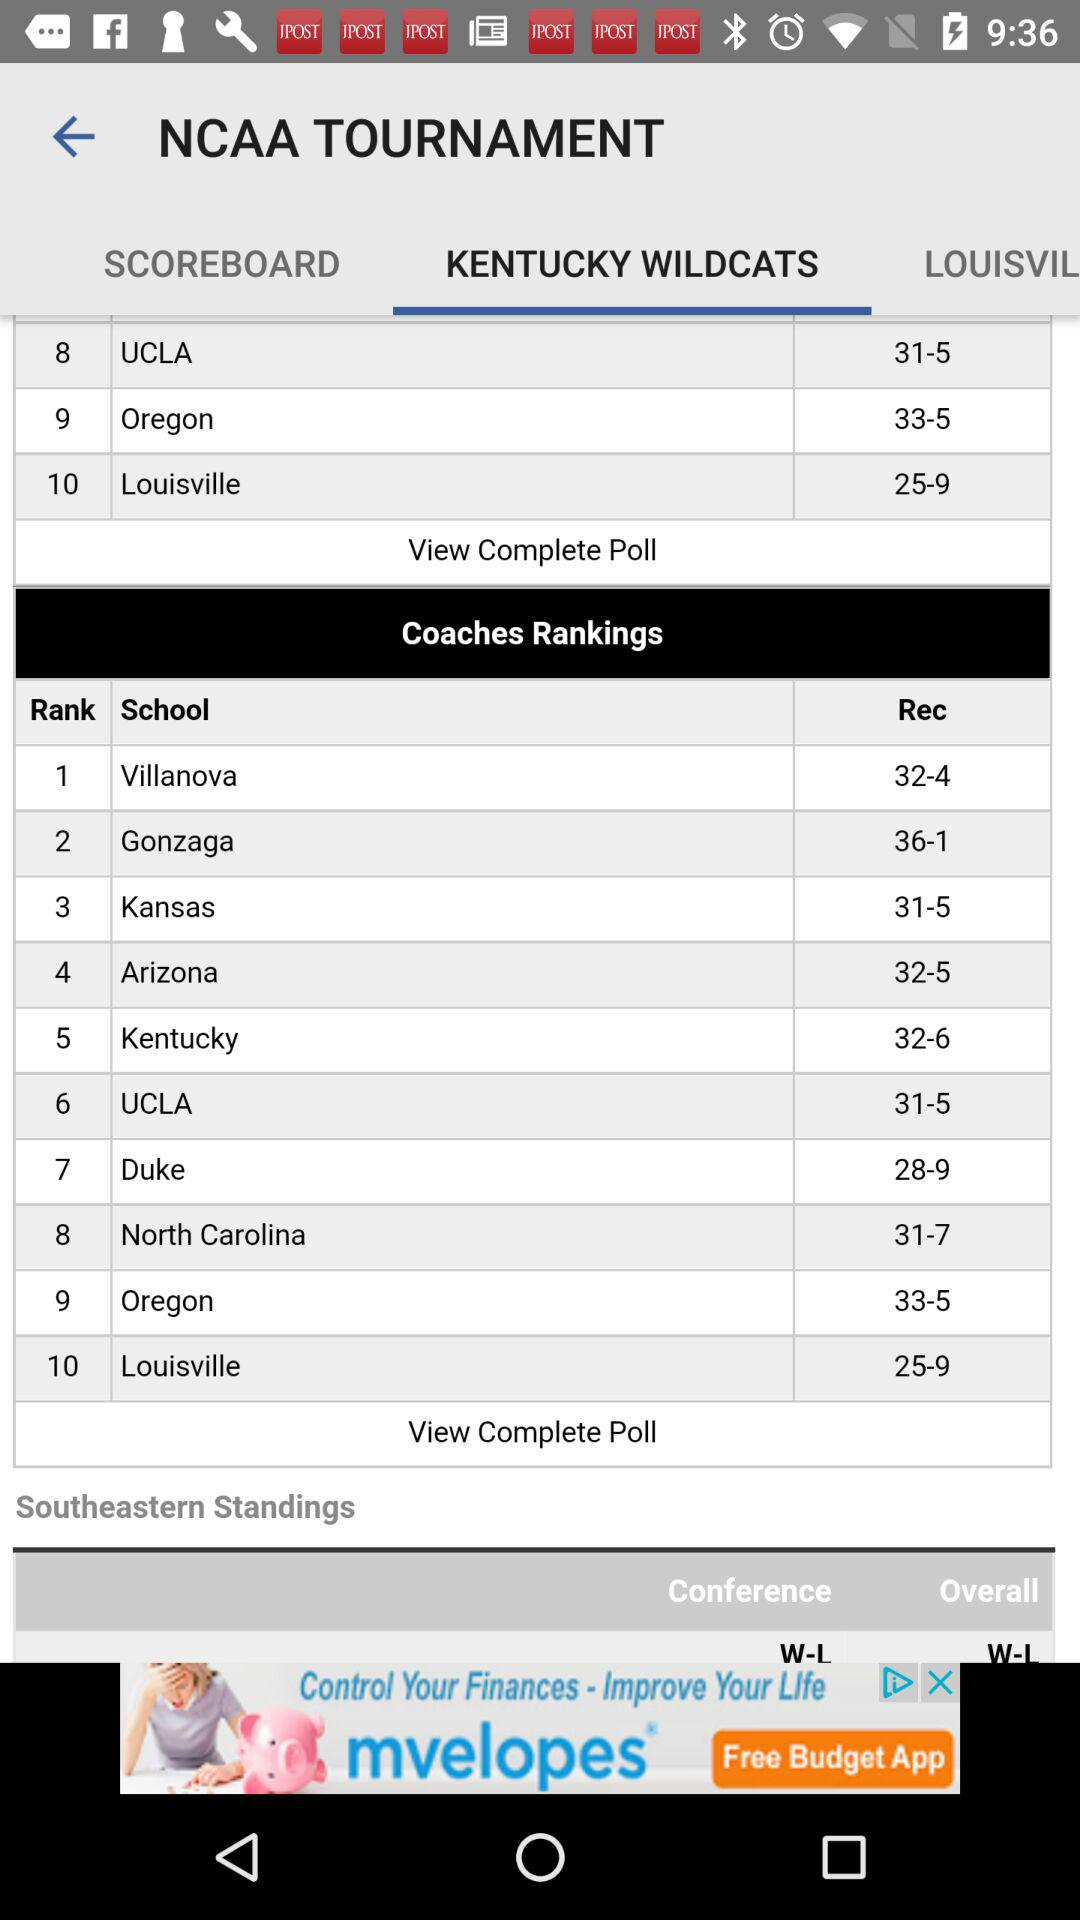What is the rank of "Arizona"? The rank of "Arizona" is fourth. 